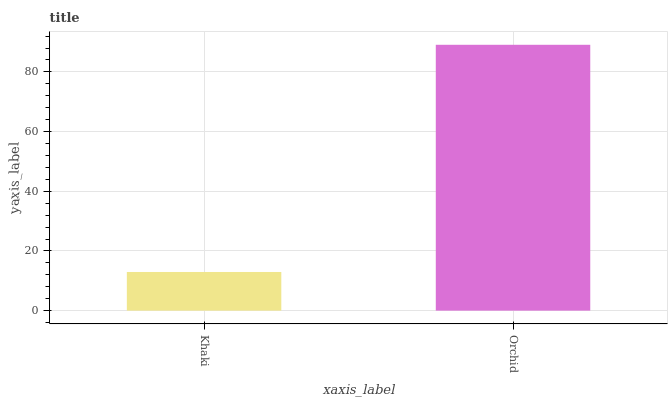Is Khaki the minimum?
Answer yes or no. Yes. Is Orchid the maximum?
Answer yes or no. Yes. Is Orchid the minimum?
Answer yes or no. No. Is Orchid greater than Khaki?
Answer yes or no. Yes. Is Khaki less than Orchid?
Answer yes or no. Yes. Is Khaki greater than Orchid?
Answer yes or no. No. Is Orchid less than Khaki?
Answer yes or no. No. Is Orchid the high median?
Answer yes or no. Yes. Is Khaki the low median?
Answer yes or no. Yes. Is Khaki the high median?
Answer yes or no. No. Is Orchid the low median?
Answer yes or no. No. 